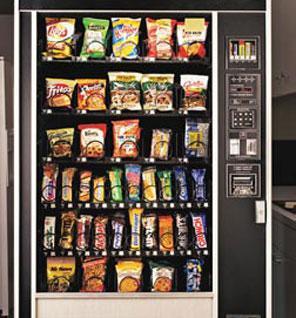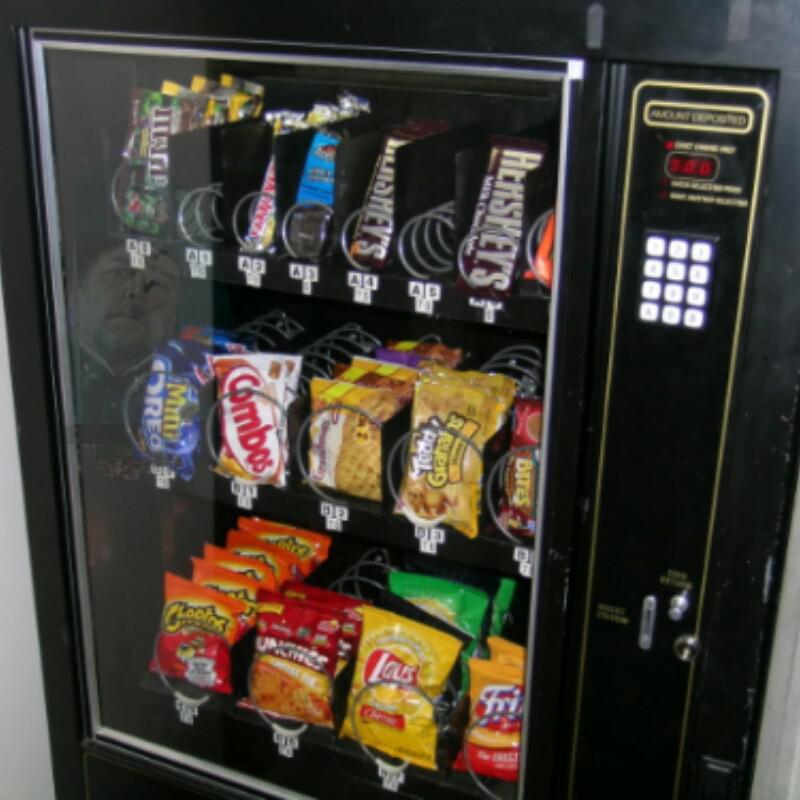The first image is the image on the left, the second image is the image on the right. For the images displayed, is the sentence "At least one vending machine is loaded with drinks." factually correct? Answer yes or no. No. 